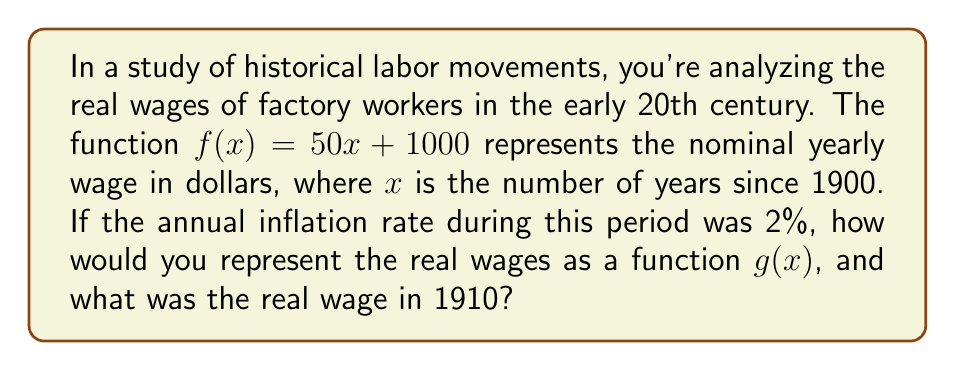Solve this math problem. 1. The nominal wage function is given as $f(x) = 50x + 1000$.

2. To account for inflation, we need to decrease the value of money over time. This is done through a vertical translation downward.

3. The inflation rate is 2% per year, which means that each year, the value of money decreases by 2% of the initial amount.

4. To calculate the cumulative effect of inflation after $x$ years:
   $1000 * (1 - 0.02)^x$

5. The real wage function $g(x)$ is the nominal wage minus the effect of inflation:
   $g(x) = f(x) - 1000 * (1 - (1 - 0.02)^x)$
   $g(x) = 50x + 1000 - 1000 * (1 - 0.98^x)$
   $g(x) = 50x + 1000 * 0.98^x$

6. To find the real wage in 1910, we calculate $g(10)$:
   $g(10) = 50(10) + 1000 * 0.98^{10}$
   $g(10) = 500 + 1000 * 0.8171$
   $g(10) = 500 + 817.10$
   $g(10) = 1317.10$
Answer: $g(x) = 50x + 1000 * 0.98^x$; $1317.10 